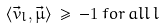<formula> <loc_0><loc_0><loc_500><loc_500>\langle { \vec { v } } _ { l } , { \vec { \mu } } \rangle \, \geq \, - 1 \, f o r \, a l l \, l</formula> 